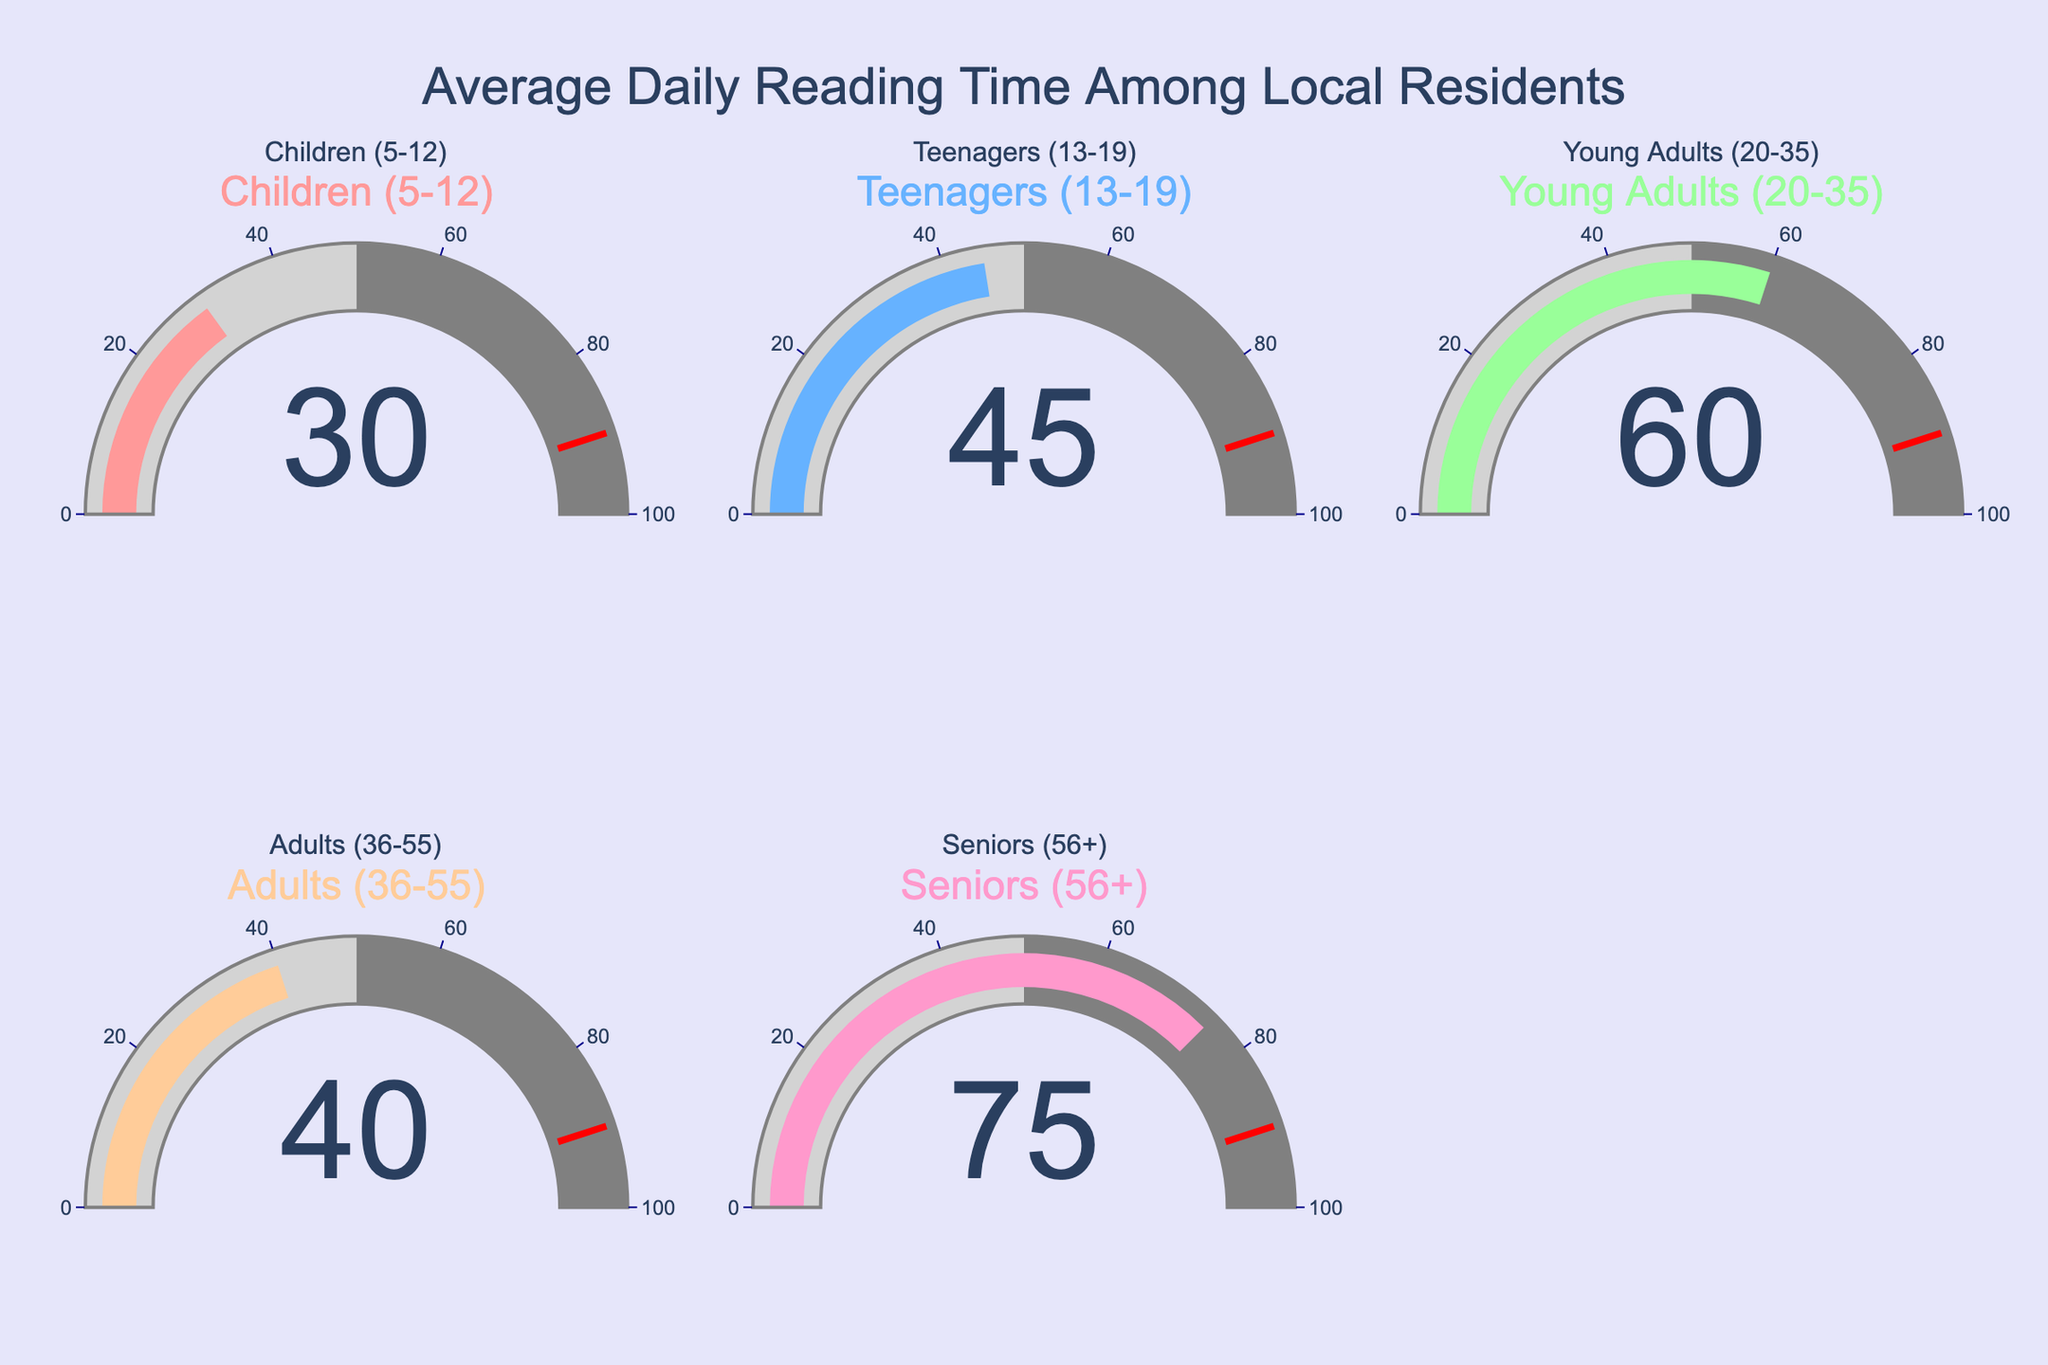What is the average daily reading time for Children (5-12)? Refer to the gauge labeled "Children (5-12)", which shows a value of 30 minutes.
Answer: 30 minutes Which age group has the highest average daily reading time? Compare the values on all gauges: Children (30), Teenagers (45), Young Adults (60), Adults (40), Seniors (75). Seniors have the highest value, 75 minutes.
Answer: Seniors What is the total average daily reading time of all age groups combined? Sum the values of all gauges: 30 (Children) + 45 (Teenagers) + 60 (Young Adults) + 40 (Adults) + 75 (Seniors) = 250 minutes.
Answer: 250 minutes How much more do Seniors read daily compared to Teenagers? Subtract the value for Teenagers (45) from Seniors (75): 75 - 45 = 30 minutes.
Answer: 30 minutes Which age group reads the least on average, and what is their reading time? Compare the values on all gauges: Children (30), Teenagers (45), Young Adults (60), Adults (40), Seniors (75). Children have the lowest value, 30 minutes.
Answer: Children, 30 minutes What is the average reading time among Teenagers (13-19) and Adults (36-55)? Add the values for Teenagers (45) and Adults (40), then divide by 2: (45 + 40) / 2 = 42.5 minutes.
Answer: 42.5 minutes Which age group reads more, Young Adults (20-35) or Adults (36-55)? Compare the values of Young Adults (60) and Adults (40). Young Adults read 60 minutes, which is more.
Answer: Young Adults What is the difference in average daily reading time between Young Adults and Children? Subtract Children (30) from Young Adults (60): 60 - 30 = 30 minutes.
Answer: 30 minutes What is the combined average daily reading time for Children, Teenagers, and Young Adults? Add the values: Children (30) + Teenagers (45) + Young Adults (60) = 135 minutes.
Answer: 135 minutes What is the median average daily reading time among the age groups shown? Arrange the values: 30 (Children), 40 (Adults), 45 (Teenagers), 60 (Young Adults), 75 (Seniors). The median value is the middle number: 45 minutes for Teenagers.
Answer: 45 minutes 